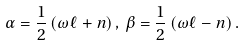Convert formula to latex. <formula><loc_0><loc_0><loc_500><loc_500>\alpha = \frac { 1 } { 2 } \left ( \omega \ell + n \right ) , \, \beta = \frac { 1 } { 2 } \left ( \omega \ell - n \right ) .</formula> 